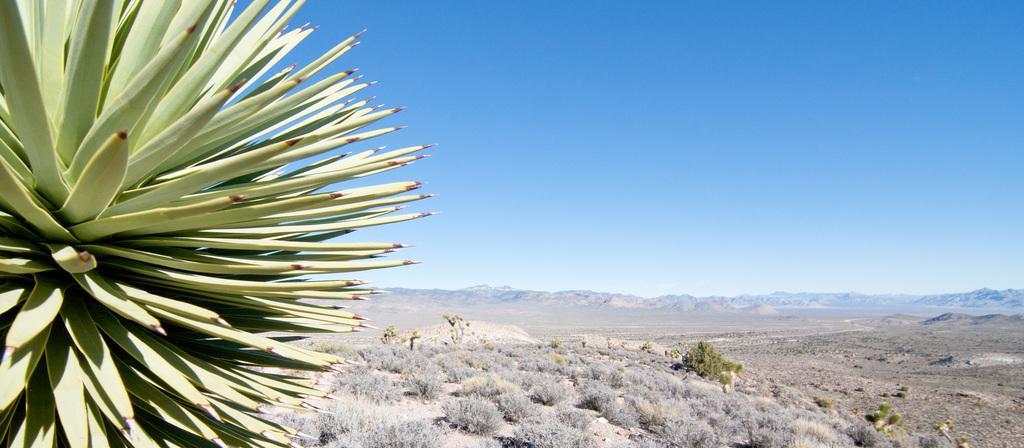Please provide a concise description of this image. In this picture we can see trees on the ground and in the background we can see mountains, sky. 